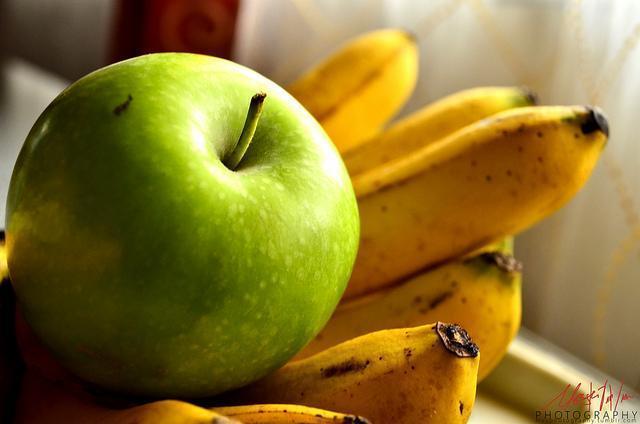How many bananas are there?
Give a very brief answer. 1. How many people are men?
Give a very brief answer. 0. 